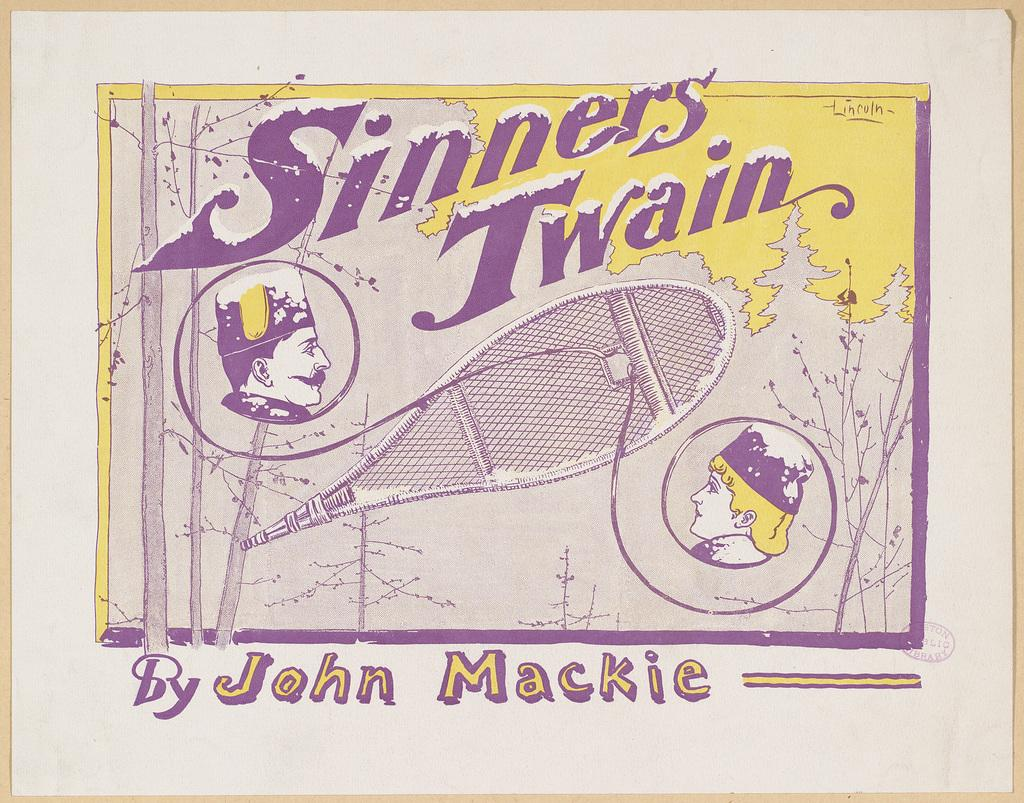What is the main subject of the paper in the image? The paper contains pictures of two people, images of a bay, and images of trees. What else is present on the paper besides the images? The paper contains text. What type of event is depicted in the images of the bay on the paper? There is no specific event depicted in the images of the bay on the paper; it simply shows a bay with trees. Can you tell me how many questions are present on the paper? There is no information about the number of questions on the paper, as the facts provided only mention the presence of text. 